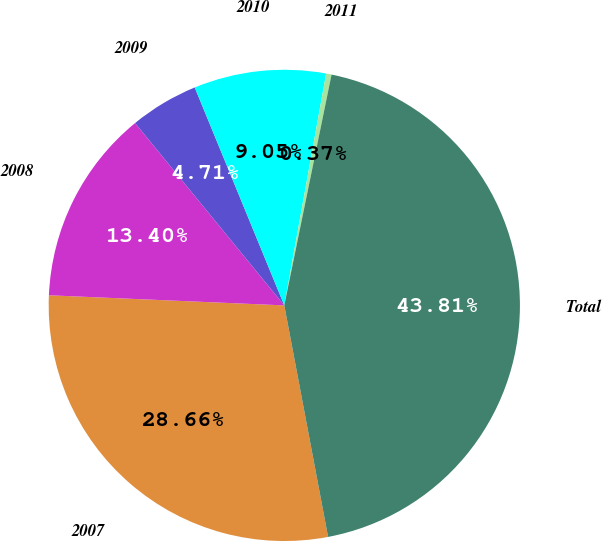<chart> <loc_0><loc_0><loc_500><loc_500><pie_chart><fcel>2007<fcel>2008<fcel>2009<fcel>2010<fcel>2011<fcel>Total<nl><fcel>28.66%<fcel>13.4%<fcel>4.71%<fcel>9.05%<fcel>0.37%<fcel>43.81%<nl></chart> 